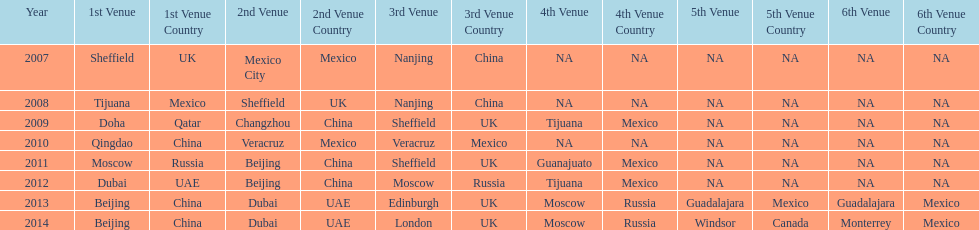Which year had more venues, 2007 or 2012? 2012. 